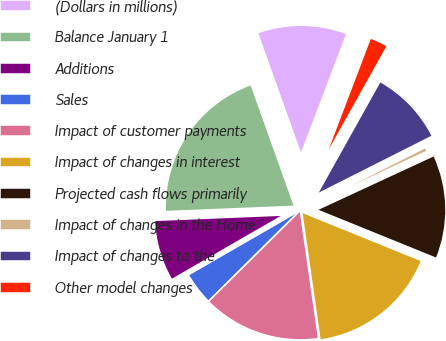<chart> <loc_0><loc_0><loc_500><loc_500><pie_chart><fcel>(Dollars in millions)<fcel>Balance January 1<fcel>Additions<fcel>Sales<fcel>Impact of customer payments<fcel>Impact of changes in interest<fcel>Projected cash flows primarily<fcel>Impact of changes in the Home<fcel>Impact of changes to the<fcel>Other model changes<nl><fcel>11.25%<fcel>20.19%<fcel>7.68%<fcel>4.1%<fcel>14.83%<fcel>16.61%<fcel>13.04%<fcel>0.53%<fcel>9.46%<fcel>2.32%<nl></chart> 